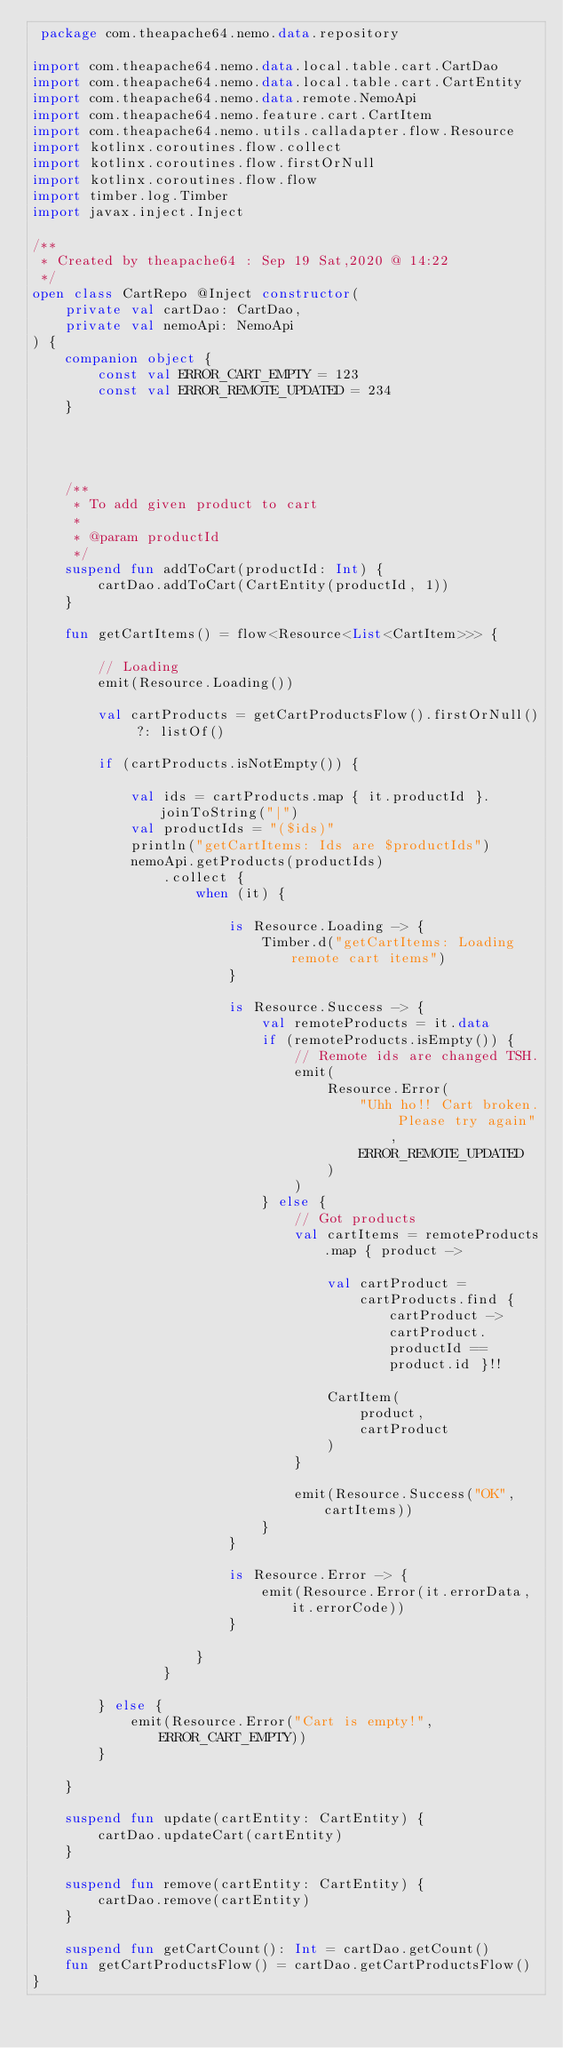Convert code to text. <code><loc_0><loc_0><loc_500><loc_500><_Kotlin_> package com.theapache64.nemo.data.repository

import com.theapache64.nemo.data.local.table.cart.CartDao
import com.theapache64.nemo.data.local.table.cart.CartEntity
import com.theapache64.nemo.data.remote.NemoApi
import com.theapache64.nemo.feature.cart.CartItem
import com.theapache64.nemo.utils.calladapter.flow.Resource
import kotlinx.coroutines.flow.collect
import kotlinx.coroutines.flow.firstOrNull
import kotlinx.coroutines.flow.flow
import timber.log.Timber
import javax.inject.Inject

/**
 * Created by theapache64 : Sep 19 Sat,2020 @ 14:22
 */
open class CartRepo @Inject constructor(
    private val cartDao: CartDao,
    private val nemoApi: NemoApi
) {
    companion object {
        const val ERROR_CART_EMPTY = 123
        const val ERROR_REMOTE_UPDATED = 234
    }




    /**
     * To add given product to cart
     *
     * @param productId
     */
    suspend fun addToCart(productId: Int) {
        cartDao.addToCart(CartEntity(productId, 1))
    }

    fun getCartItems() = flow<Resource<List<CartItem>>> {

        // Loading
        emit(Resource.Loading())

        val cartProducts = getCartProductsFlow().firstOrNull() ?: listOf()

        if (cartProducts.isNotEmpty()) {

            val ids = cartProducts.map { it.productId }.joinToString("|")
            val productIds = "($ids)"
            println("getCartItems: Ids are $productIds")
            nemoApi.getProducts(productIds)
                .collect {
                    when (it) {

                        is Resource.Loading -> {
                            Timber.d("getCartItems: Loading remote cart items")
                        }

                        is Resource.Success -> {
                            val remoteProducts = it.data
                            if (remoteProducts.isEmpty()) {
                                // Remote ids are changed TSH.
                                emit(
                                    Resource.Error(
                                        "Uhh ho!! Cart broken. Please try again",
                                        ERROR_REMOTE_UPDATED
                                    )
                                )
                            } else {
                                // Got products
                                val cartItems = remoteProducts.map { product ->

                                    val cartProduct =
                                        cartProducts.find { cartProduct -> cartProduct.productId == product.id }!!

                                    CartItem(
                                        product,
                                        cartProduct
                                    )
                                }

                                emit(Resource.Success("OK", cartItems))
                            }
                        }

                        is Resource.Error -> {
                            emit(Resource.Error(it.errorData, it.errorCode))
                        }

                    }
                }

        } else {
            emit(Resource.Error("Cart is empty!", ERROR_CART_EMPTY))
        }

    }

    suspend fun update(cartEntity: CartEntity) {
        cartDao.updateCart(cartEntity)
    }

    suspend fun remove(cartEntity: CartEntity) {
        cartDao.remove(cartEntity)
    }

    suspend fun getCartCount(): Int = cartDao.getCount()
    fun getCartProductsFlow() = cartDao.getCartProductsFlow()
}</code> 